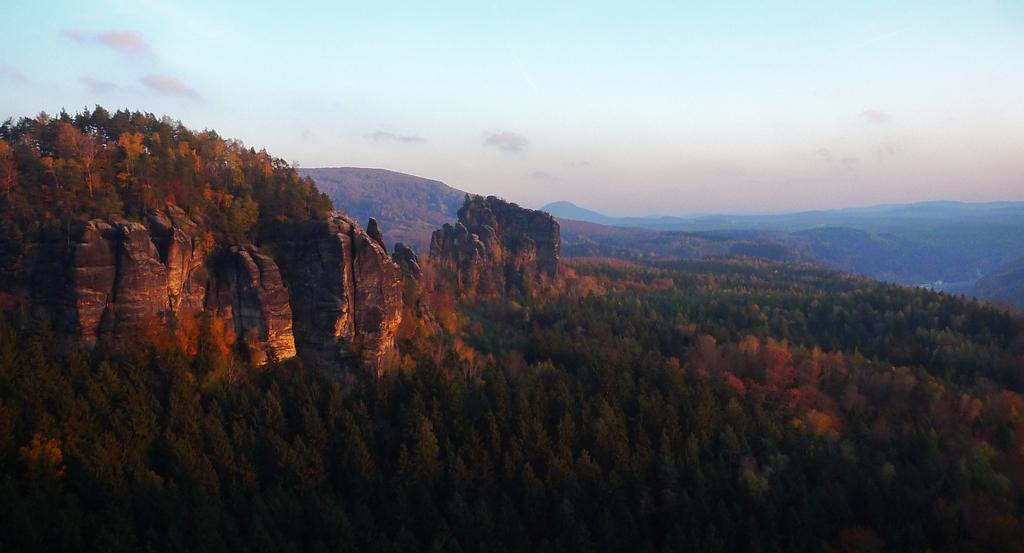What type of natural environment is depicted in the image? The image features many trees, mountains, and clouds, suggesting a natural landscape. Can you describe the sky in the image? The sky is visible in the image, and it appears to have clouds. What type of terrain can be seen in the image? The image includes mountains, which are a type of terrain. How many books can be seen on the tiger's back in the image? There are no books or tigers present in the image; it features a natural landscape with trees, mountains, and clouds. 